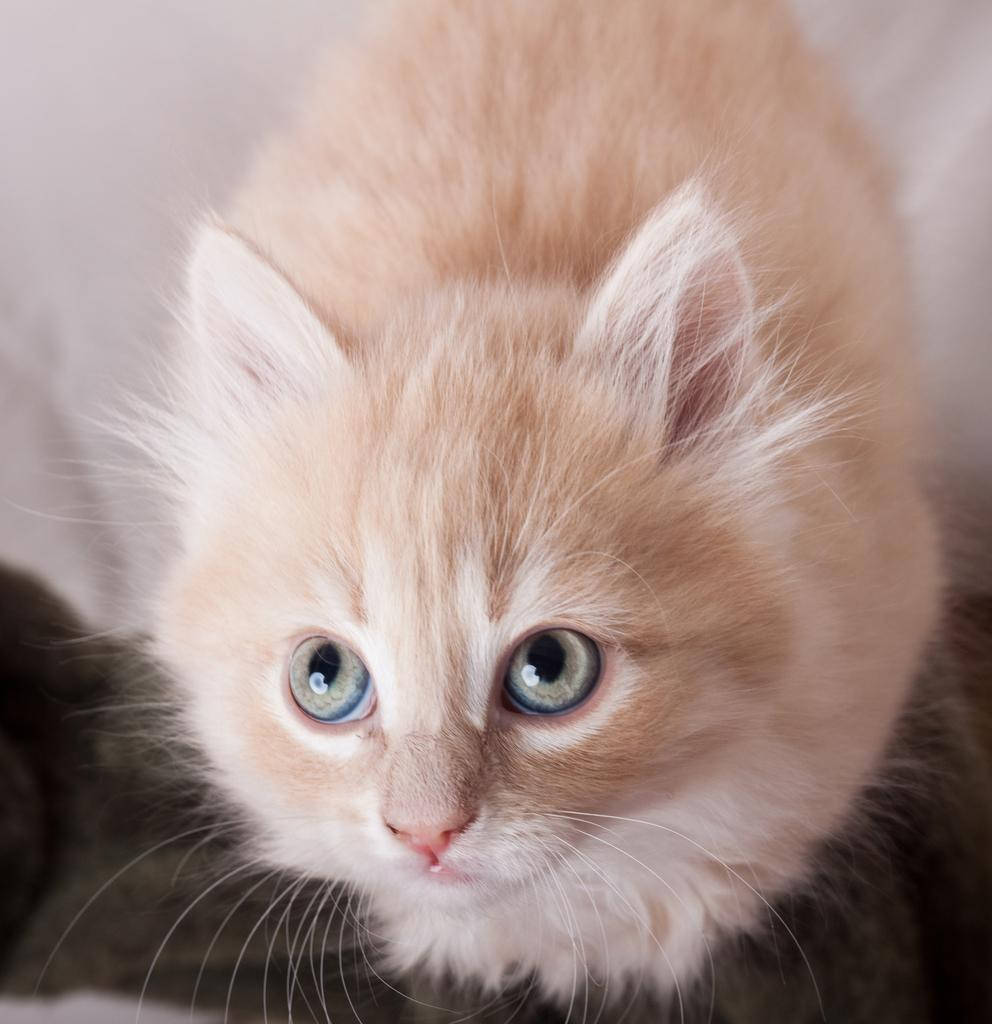What type of animal is present in the image? There is a cat in the image. Can you describe the cat's appearance or behavior in the image? The provided facts do not mention any specific details about the cat's appearance or behavior. Where is the nearest market to the cat in the image? The provided facts do not mention any information about a market or its location in relation to the cat in the image. 